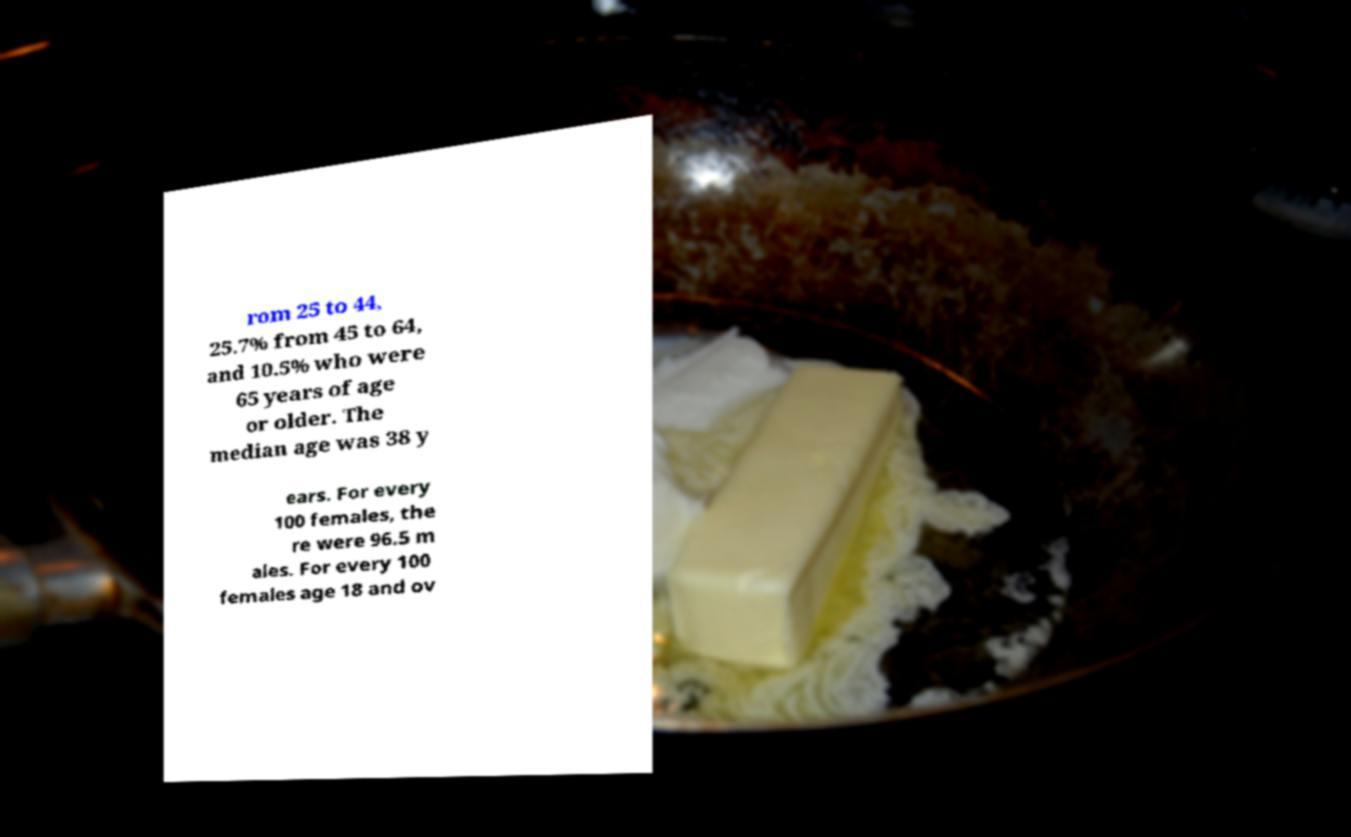Can you read and provide the text displayed in the image?This photo seems to have some interesting text. Can you extract and type it out for me? rom 25 to 44, 25.7% from 45 to 64, and 10.5% who were 65 years of age or older. The median age was 38 y ears. For every 100 females, the re were 96.5 m ales. For every 100 females age 18 and ov 